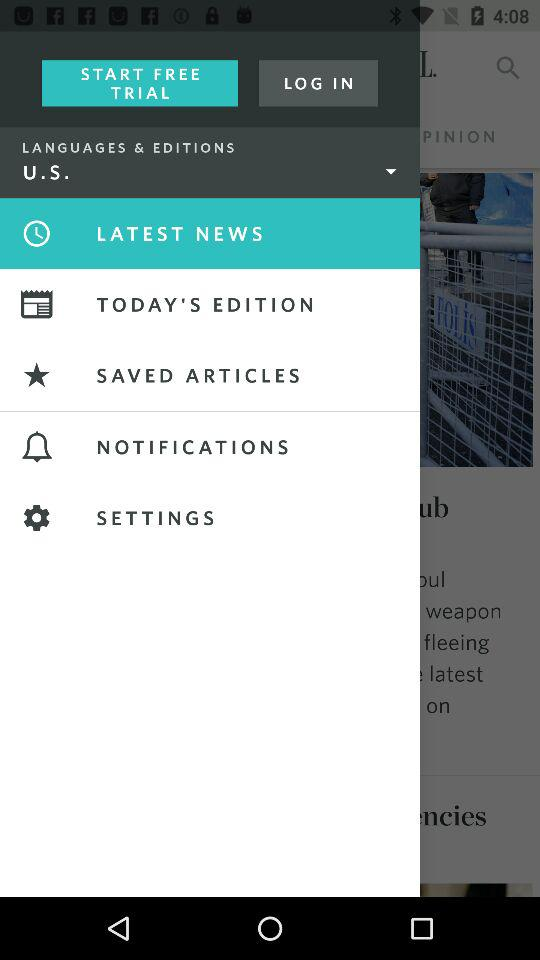Which option is selected in "LANGUAGES & EDITIONS"? The selected option is "U.S.". 